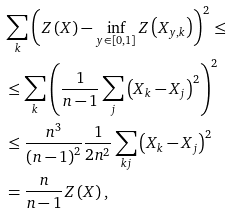Convert formula to latex. <formula><loc_0><loc_0><loc_500><loc_500>& \sum _ { k } \left ( Z \left ( X \right ) - \inf _ { y \in \left [ 0 , 1 \right ] } Z \left ( X _ { y , k } \right ) \right ) ^ { 2 } \leq \\ & \leq \sum _ { k } \left ( \frac { 1 } { n - 1 } \sum _ { j } \left ( X _ { k } - X _ { j } \right ) ^ { 2 } \right ) ^ { 2 } \\ & \leq \frac { n ^ { 3 } } { \left ( n - 1 \right ) ^ { 2 } } \frac { 1 } { 2 n ^ { 2 } } \sum _ { k j } \left ( X _ { k } - X _ { j } \right ) ^ { 2 } \\ & = \frac { n } { n - 1 } Z \left ( X \right ) ,</formula> 